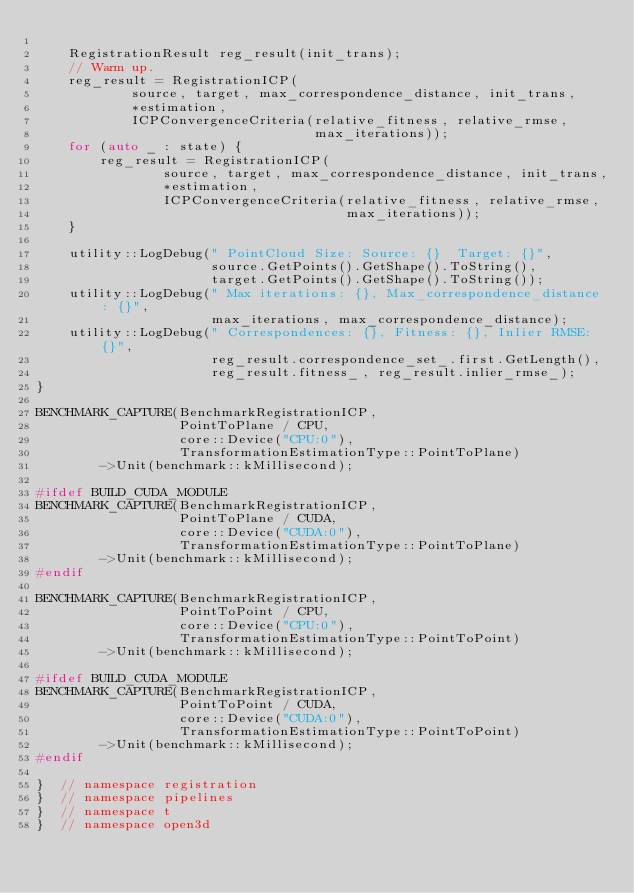<code> <loc_0><loc_0><loc_500><loc_500><_C++_>
    RegistrationResult reg_result(init_trans);
    // Warm up.
    reg_result = RegistrationICP(
            source, target, max_correspondence_distance, init_trans,
            *estimation,
            ICPConvergenceCriteria(relative_fitness, relative_rmse,
                                   max_iterations));
    for (auto _ : state) {
        reg_result = RegistrationICP(
                source, target, max_correspondence_distance, init_trans,
                *estimation,
                ICPConvergenceCriteria(relative_fitness, relative_rmse,
                                       max_iterations));
    }

    utility::LogDebug(" PointCloud Size: Source: {}  Target: {}",
                      source.GetPoints().GetShape().ToString(),
                      target.GetPoints().GetShape().ToString());
    utility::LogDebug(" Max iterations: {}, Max_correspondence_distance : {}",
                      max_iterations, max_correspondence_distance);
    utility::LogDebug(" Correspondences: {}, Fitness: {}, Inlier RMSE: {}",
                      reg_result.correspondence_set_.first.GetLength(),
                      reg_result.fitness_, reg_result.inlier_rmse_);
}

BENCHMARK_CAPTURE(BenchmarkRegistrationICP,
                  PointToPlane / CPU,
                  core::Device("CPU:0"),
                  TransformationEstimationType::PointToPlane)
        ->Unit(benchmark::kMillisecond);

#ifdef BUILD_CUDA_MODULE
BENCHMARK_CAPTURE(BenchmarkRegistrationICP,
                  PointToPlane / CUDA,
                  core::Device("CUDA:0"),
                  TransformationEstimationType::PointToPlane)
        ->Unit(benchmark::kMillisecond);
#endif

BENCHMARK_CAPTURE(BenchmarkRegistrationICP,
                  PointToPoint / CPU,
                  core::Device("CPU:0"),
                  TransformationEstimationType::PointToPoint)
        ->Unit(benchmark::kMillisecond);

#ifdef BUILD_CUDA_MODULE
BENCHMARK_CAPTURE(BenchmarkRegistrationICP,
                  PointToPoint / CUDA,
                  core::Device("CUDA:0"),
                  TransformationEstimationType::PointToPoint)
        ->Unit(benchmark::kMillisecond);
#endif

}  // namespace registration
}  // namespace pipelines
}  // namespace t
}  // namespace open3d
</code> 